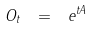Convert formula to latex. <formula><loc_0><loc_0><loc_500><loc_500>O _ { t } \ = \ e ^ { t A }</formula> 